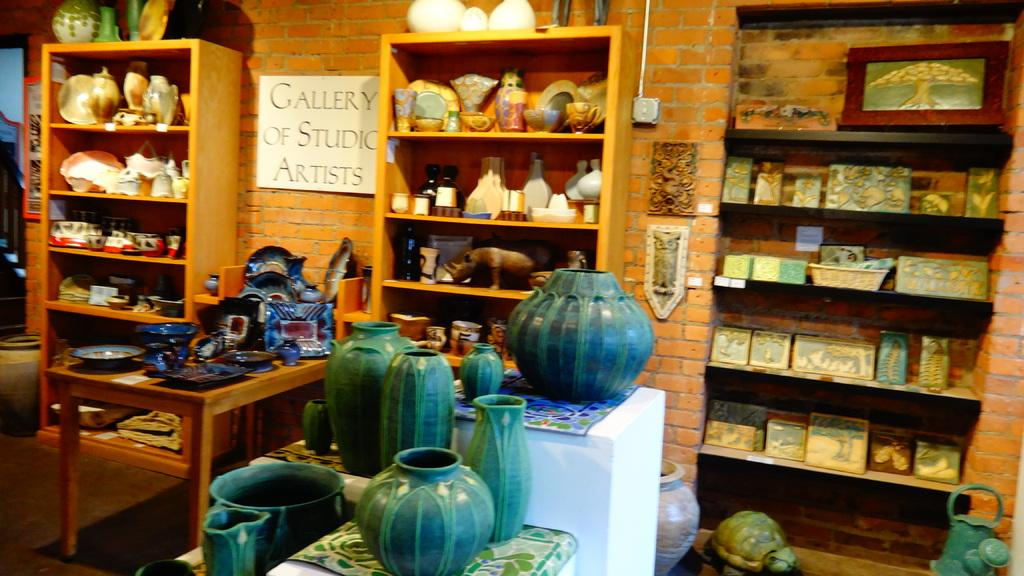<image>
Summarize the visual content of the image. Several pots arrangewd on a pillar display with the sign gallery of studio artists. 